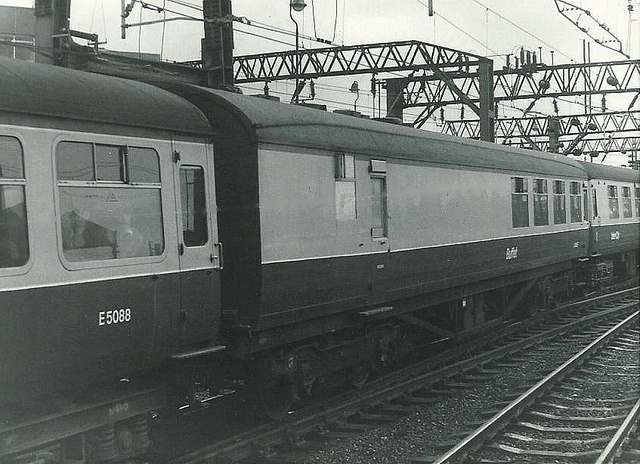Describe the objects in this image and their specific colors. I can see train in ivory, black, gray, and darkgray tones, people in ivory and gray tones, and people in ivory and gray tones in this image. 